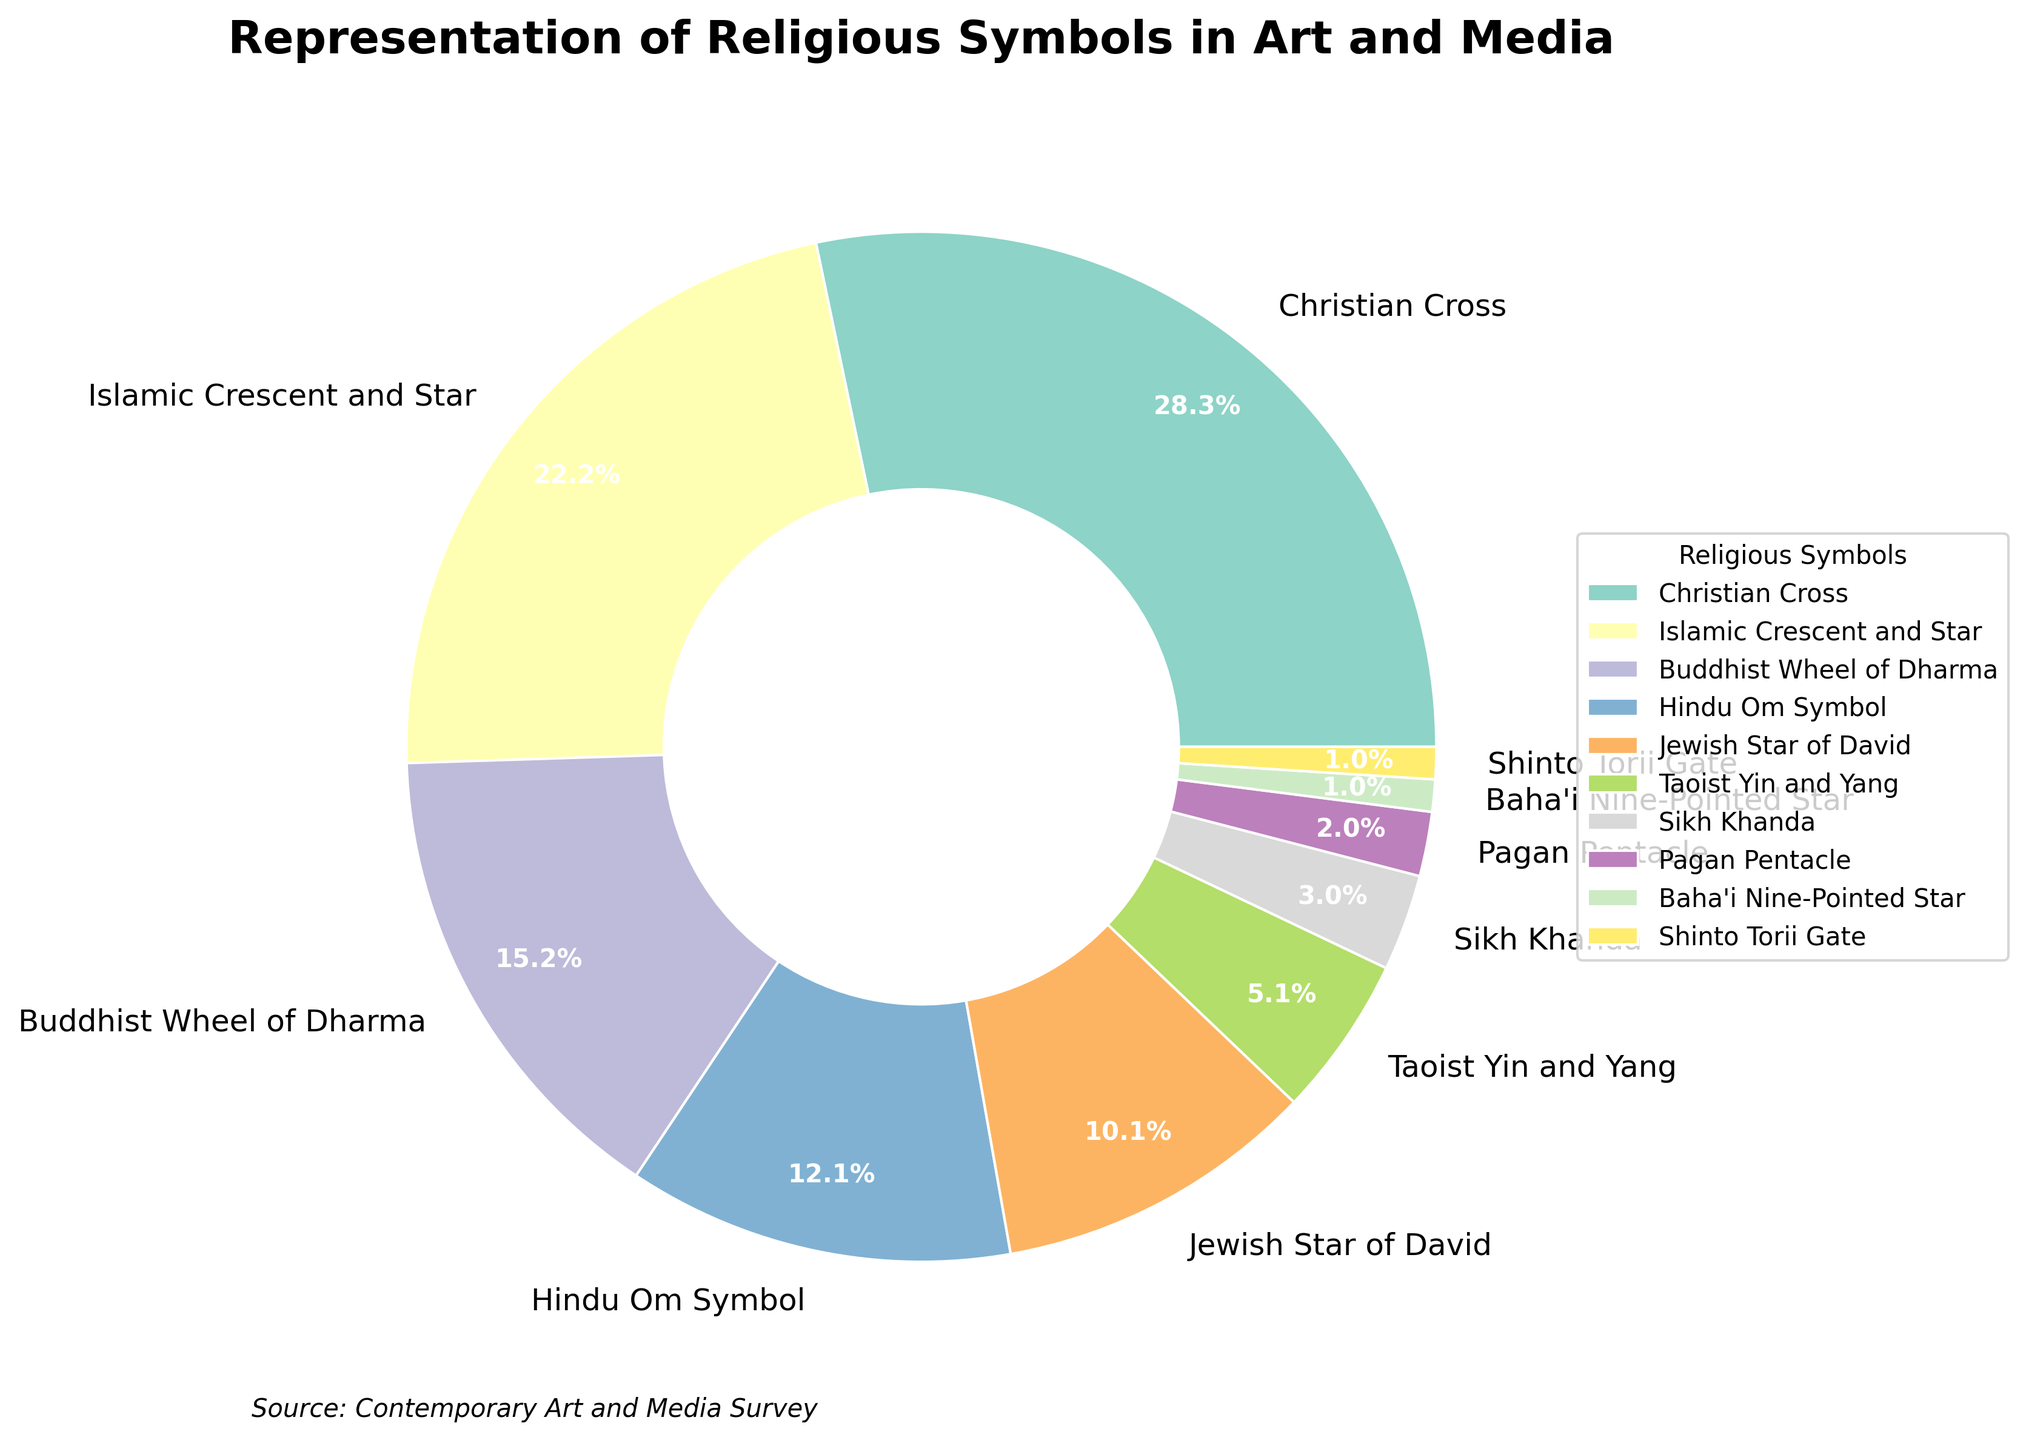Which symbol has the highest representation in the chart? The Christian Cross has the largest percentage section at 28%.
Answer: Christian Cross Which two symbols together make up approximately half of the representation? Adding the percentages of the Christian Cross (28%) and the Islamic Crescent and Star (22%) gives 50%.
Answer: Christian Cross and Islamic Crescent and Star How much larger is the percentage of the Buddhist Wheel of Dharma compared to the Hindu Om Symbol? The Buddhist Wheel of Dharma (15%) minus the Hindu Om Symbol (12%) is 3%.
Answer: 3% What is the combined representation of the Jewish Star of David, Taoist Yin and Yang, and Sikh Khanda symbols? Summing the percentages of the Jewish Star of David (10%), Taoist Yin and Yang (5%), and Sikh Khanda (3%) gives 18%.
Answer: 18% How many symbols are represented with less than 5%? There are five symbols with less than 5%: Taoist Yin and Yang, Sikh Khanda, Pagan Pentacle, Baha'i Nine-Pointed Star, and Shinto Torii Gate.
Answer: 5 Which symbols are represented by the smallest equal percentage, and what is that percentage? The Zoroastrian Faravahar and Jain Hand Symbol both have the smallest representation at 0.5%.
Answer: Zoroastrian Faravahar and Jain Hand Symbol Compare the representation of the Hindu Om Symbol to the Pagan Pentacle. By how many times is the Hindu Om Symbol larger? The Hindu Om Symbol (12%) divided by the Pagan Pentacle (2%) is 6 times.
Answer: 6 What color is used to represent the Buddhist Wheel of Dharma in the pie chart? The pie chart uses unique colors for each symbol. The specific color for the Buddhist Wheel of Dharma can be identified visually by looking at the segment labeled with "Buddhist Wheel of Dharma."
Answer: [Answer will be visual, e.g., "Green"] Which symbol is more represented, the Jewish Star of David or the Taoist Yin and Yang? The Jewish Star of David has 10% while the Taoist Yin and Yang has 5%. Therefore, the Jewish Star of David is more represented.
Answer: Jewish Star of David Consider just the top three symbols by representation. What is their combined percentage? Adding the percentages of the Christian Cross (28%), Islamic Crescent and Star (22%), and Buddhist Wheel of Dharma (15%) gives 65%.
Answer: 65% 